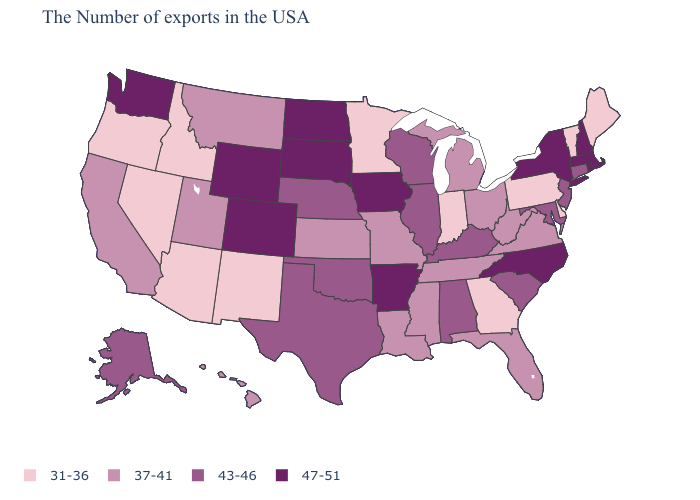Does Georgia have the lowest value in the USA?
Give a very brief answer. Yes. What is the value of Nevada?
Concise answer only. 31-36. What is the lowest value in the West?
Concise answer only. 31-36. Does the first symbol in the legend represent the smallest category?
Short answer required. Yes. How many symbols are there in the legend?
Write a very short answer. 4. Which states have the highest value in the USA?
Short answer required. Massachusetts, Rhode Island, New Hampshire, New York, North Carolina, Arkansas, Iowa, South Dakota, North Dakota, Wyoming, Colorado, Washington. What is the value of Georgia?
Keep it brief. 31-36. What is the value of Massachusetts?
Quick response, please. 47-51. What is the highest value in the USA?
Concise answer only. 47-51. Among the states that border Ohio , does West Virginia have the lowest value?
Concise answer only. No. What is the value of Indiana?
Write a very short answer. 31-36. Name the states that have a value in the range 31-36?
Concise answer only. Maine, Vermont, Delaware, Pennsylvania, Georgia, Indiana, Minnesota, New Mexico, Arizona, Idaho, Nevada, Oregon. What is the value of Connecticut?
Write a very short answer. 43-46. 